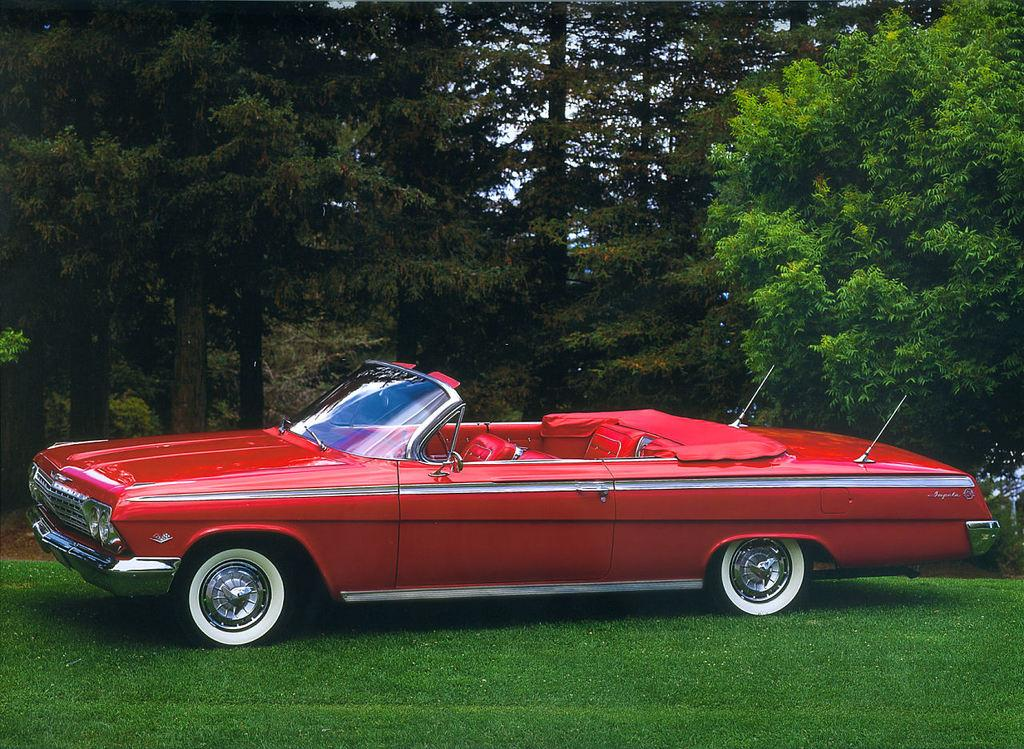What color is the car in the image? The car in the image is red. What can be seen in the background of the image? There are trees visible in the image, likely at the back side. How many fingers can be seen on the car in the image? There are no fingers visible on the car in the image. 